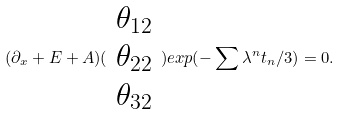Convert formula to latex. <formula><loc_0><loc_0><loc_500><loc_500>( \partial _ { x } + E + A ) ( \begin{array} { c } \theta _ { 1 2 } \\ \theta _ { 2 2 } \\ \theta _ { 3 2 } \end{array} ) e x p ( - \sum \lambda ^ { n } t _ { n } / 3 ) = 0 .</formula> 